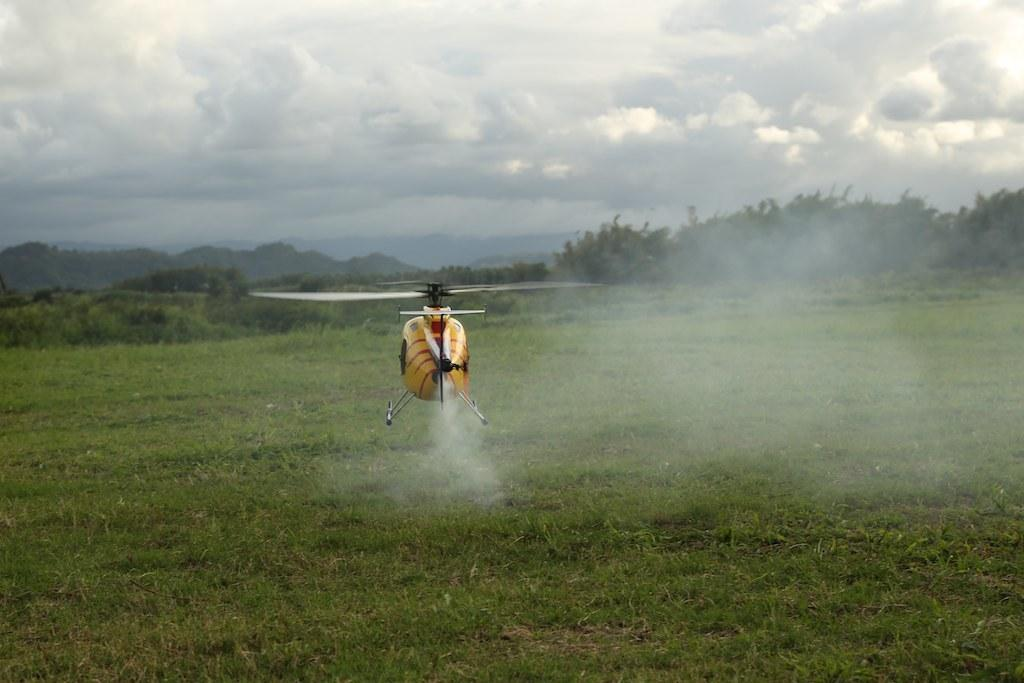What is the main subject of the image? The main subject of the image is a helicopter. What is the helicopter doing in the image? The helicopter is moving from the ground in the image. What type of vegetation can be seen in the image? There is a lot of grass and trees in the image. How many frogs are sitting on the pan in the image? There are no frogs or pans present in the image. What type of dress is the helicopter wearing in the image? Helicopters do not wear dresses, as they are machines and not people. 